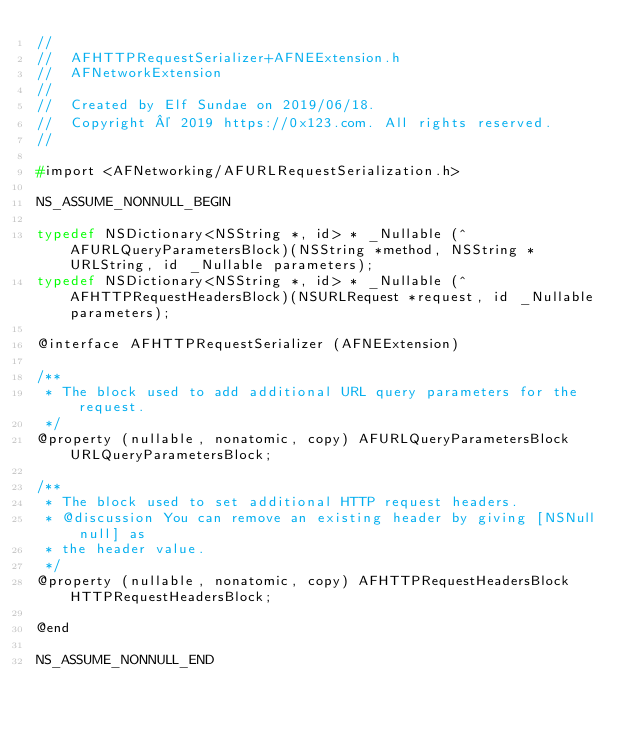Convert code to text. <code><loc_0><loc_0><loc_500><loc_500><_C_>//
//  AFHTTPRequestSerializer+AFNEExtension.h
//  AFNetworkExtension
//
//  Created by Elf Sundae on 2019/06/18.
//  Copyright © 2019 https://0x123.com. All rights reserved.
//

#import <AFNetworking/AFURLRequestSerialization.h>

NS_ASSUME_NONNULL_BEGIN

typedef NSDictionary<NSString *, id> * _Nullable (^ AFURLQueryParametersBlock)(NSString *method, NSString *URLString, id _Nullable parameters);
typedef NSDictionary<NSString *, id> * _Nullable (^ AFHTTPRequestHeadersBlock)(NSURLRequest *request, id _Nullable parameters);

@interface AFHTTPRequestSerializer (AFNEExtension)

/**
 * The block used to add additional URL query parameters for the request.
 */
@property (nullable, nonatomic, copy) AFURLQueryParametersBlock URLQueryParametersBlock;

/**
 * The block used to set additional HTTP request headers.
 * @discussion You can remove an existing header by giving [NSNull null] as
 * the header value.
 */
@property (nullable, nonatomic, copy) AFHTTPRequestHeadersBlock HTTPRequestHeadersBlock;

@end

NS_ASSUME_NONNULL_END
</code> 